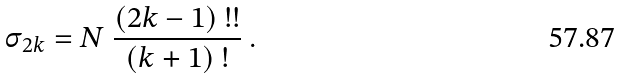<formula> <loc_0><loc_0><loc_500><loc_500>\sigma _ { 2 k } = N \ \frac { ( 2 k - 1 ) \ ! ! } { ( k + 1 ) \ ! } \ .</formula> 